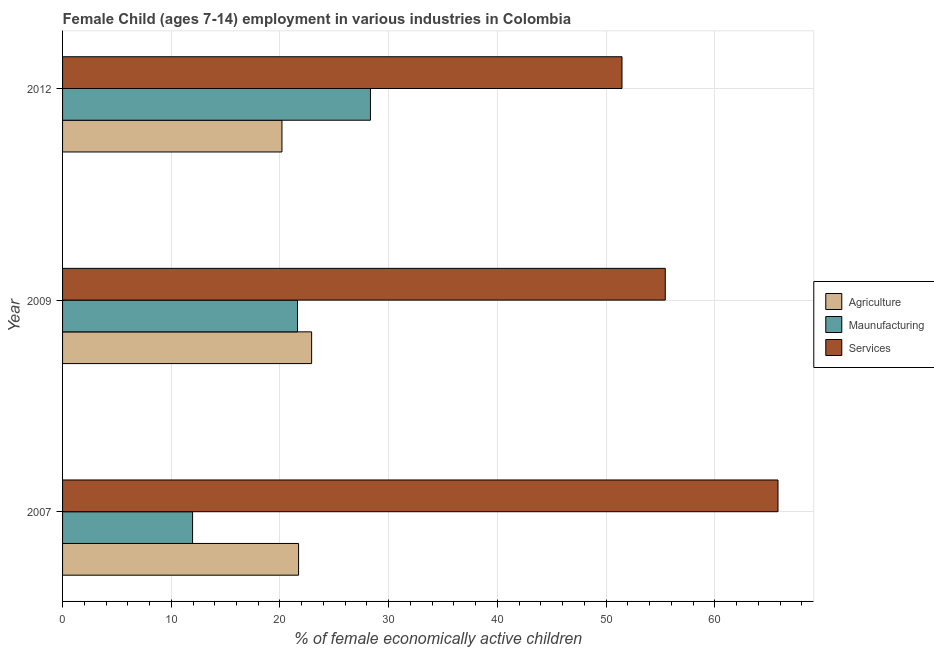How many groups of bars are there?
Provide a short and direct response. 3. Are the number of bars per tick equal to the number of legend labels?
Your response must be concise. Yes. How many bars are there on the 2nd tick from the top?
Keep it short and to the point. 3. How many bars are there on the 2nd tick from the bottom?
Your answer should be compact. 3. In how many cases, is the number of bars for a given year not equal to the number of legend labels?
Keep it short and to the point. 0. What is the percentage of economically active children in manufacturing in 2007?
Your answer should be compact. 11.96. Across all years, what is the maximum percentage of economically active children in agriculture?
Ensure brevity in your answer.  22.91. Across all years, what is the minimum percentage of economically active children in manufacturing?
Keep it short and to the point. 11.96. What is the total percentage of economically active children in agriculture in the graph?
Your response must be concise. 64.8. What is the difference between the percentage of economically active children in services in 2009 and that in 2012?
Make the answer very short. 3.98. What is the difference between the percentage of economically active children in manufacturing in 2007 and the percentage of economically active children in services in 2009?
Keep it short and to the point. -43.48. What is the average percentage of economically active children in services per year?
Your answer should be very brief. 57.57. In the year 2009, what is the difference between the percentage of economically active children in services and percentage of economically active children in agriculture?
Offer a terse response. 32.53. What is the ratio of the percentage of economically active children in agriculture in 2007 to that in 2012?
Give a very brief answer. 1.08. Is the percentage of economically active children in manufacturing in 2007 less than that in 2012?
Ensure brevity in your answer.  Yes. Is the difference between the percentage of economically active children in services in 2007 and 2009 greater than the difference between the percentage of economically active children in manufacturing in 2007 and 2009?
Offer a terse response. Yes. What is the difference between the highest and the second highest percentage of economically active children in manufacturing?
Your answer should be very brief. 6.71. What is the difference between the highest and the lowest percentage of economically active children in manufacturing?
Offer a terse response. 16.36. In how many years, is the percentage of economically active children in services greater than the average percentage of economically active children in services taken over all years?
Your response must be concise. 1. Is the sum of the percentage of economically active children in agriculture in 2007 and 2012 greater than the maximum percentage of economically active children in services across all years?
Your answer should be compact. No. What does the 1st bar from the top in 2009 represents?
Ensure brevity in your answer.  Services. What does the 3rd bar from the bottom in 2009 represents?
Your response must be concise. Services. Is it the case that in every year, the sum of the percentage of economically active children in agriculture and percentage of economically active children in manufacturing is greater than the percentage of economically active children in services?
Offer a terse response. No. How many years are there in the graph?
Your answer should be very brief. 3. Are the values on the major ticks of X-axis written in scientific E-notation?
Your answer should be very brief. No. Does the graph contain any zero values?
Provide a succinct answer. No. Does the graph contain grids?
Make the answer very short. Yes. How many legend labels are there?
Your answer should be compact. 3. How are the legend labels stacked?
Offer a terse response. Vertical. What is the title of the graph?
Your response must be concise. Female Child (ages 7-14) employment in various industries in Colombia. Does "Ireland" appear as one of the legend labels in the graph?
Keep it short and to the point. No. What is the label or title of the X-axis?
Ensure brevity in your answer.  % of female economically active children. What is the label or title of the Y-axis?
Your answer should be compact. Year. What is the % of female economically active children in Agriculture in 2007?
Ensure brevity in your answer.  21.71. What is the % of female economically active children in Maunufacturing in 2007?
Your answer should be compact. 11.96. What is the % of female economically active children of Services in 2007?
Your answer should be very brief. 65.81. What is the % of female economically active children of Agriculture in 2009?
Ensure brevity in your answer.  22.91. What is the % of female economically active children in Maunufacturing in 2009?
Your response must be concise. 21.61. What is the % of female economically active children of Services in 2009?
Offer a very short reply. 55.44. What is the % of female economically active children in Agriculture in 2012?
Keep it short and to the point. 20.18. What is the % of female economically active children of Maunufacturing in 2012?
Keep it short and to the point. 28.32. What is the % of female economically active children in Services in 2012?
Ensure brevity in your answer.  51.46. Across all years, what is the maximum % of female economically active children in Agriculture?
Make the answer very short. 22.91. Across all years, what is the maximum % of female economically active children of Maunufacturing?
Give a very brief answer. 28.32. Across all years, what is the maximum % of female economically active children of Services?
Provide a short and direct response. 65.81. Across all years, what is the minimum % of female economically active children in Agriculture?
Your response must be concise. 20.18. Across all years, what is the minimum % of female economically active children in Maunufacturing?
Your answer should be very brief. 11.96. Across all years, what is the minimum % of female economically active children of Services?
Your answer should be very brief. 51.46. What is the total % of female economically active children of Agriculture in the graph?
Make the answer very short. 64.8. What is the total % of female economically active children of Maunufacturing in the graph?
Your answer should be very brief. 61.89. What is the total % of female economically active children in Services in the graph?
Provide a succinct answer. 172.71. What is the difference between the % of female economically active children in Maunufacturing in 2007 and that in 2009?
Give a very brief answer. -9.65. What is the difference between the % of female economically active children in Services in 2007 and that in 2009?
Your answer should be compact. 10.37. What is the difference between the % of female economically active children of Agriculture in 2007 and that in 2012?
Ensure brevity in your answer.  1.53. What is the difference between the % of female economically active children of Maunufacturing in 2007 and that in 2012?
Offer a very short reply. -16.36. What is the difference between the % of female economically active children of Services in 2007 and that in 2012?
Ensure brevity in your answer.  14.35. What is the difference between the % of female economically active children in Agriculture in 2009 and that in 2012?
Make the answer very short. 2.73. What is the difference between the % of female economically active children in Maunufacturing in 2009 and that in 2012?
Ensure brevity in your answer.  -6.71. What is the difference between the % of female economically active children of Services in 2009 and that in 2012?
Your answer should be very brief. 3.98. What is the difference between the % of female economically active children of Agriculture in 2007 and the % of female economically active children of Maunufacturing in 2009?
Offer a terse response. 0.1. What is the difference between the % of female economically active children in Agriculture in 2007 and the % of female economically active children in Services in 2009?
Give a very brief answer. -33.73. What is the difference between the % of female economically active children of Maunufacturing in 2007 and the % of female economically active children of Services in 2009?
Your answer should be compact. -43.48. What is the difference between the % of female economically active children in Agriculture in 2007 and the % of female economically active children in Maunufacturing in 2012?
Your answer should be compact. -6.61. What is the difference between the % of female economically active children in Agriculture in 2007 and the % of female economically active children in Services in 2012?
Your answer should be very brief. -29.75. What is the difference between the % of female economically active children in Maunufacturing in 2007 and the % of female economically active children in Services in 2012?
Offer a very short reply. -39.5. What is the difference between the % of female economically active children in Agriculture in 2009 and the % of female economically active children in Maunufacturing in 2012?
Your answer should be very brief. -5.41. What is the difference between the % of female economically active children of Agriculture in 2009 and the % of female economically active children of Services in 2012?
Give a very brief answer. -28.55. What is the difference between the % of female economically active children in Maunufacturing in 2009 and the % of female economically active children in Services in 2012?
Offer a very short reply. -29.85. What is the average % of female economically active children of Agriculture per year?
Your answer should be compact. 21.6. What is the average % of female economically active children in Maunufacturing per year?
Make the answer very short. 20.63. What is the average % of female economically active children in Services per year?
Provide a short and direct response. 57.57. In the year 2007, what is the difference between the % of female economically active children in Agriculture and % of female economically active children in Maunufacturing?
Offer a very short reply. 9.75. In the year 2007, what is the difference between the % of female economically active children in Agriculture and % of female economically active children in Services?
Your answer should be compact. -44.1. In the year 2007, what is the difference between the % of female economically active children of Maunufacturing and % of female economically active children of Services?
Your response must be concise. -53.85. In the year 2009, what is the difference between the % of female economically active children in Agriculture and % of female economically active children in Maunufacturing?
Ensure brevity in your answer.  1.3. In the year 2009, what is the difference between the % of female economically active children of Agriculture and % of female economically active children of Services?
Offer a terse response. -32.53. In the year 2009, what is the difference between the % of female economically active children in Maunufacturing and % of female economically active children in Services?
Your answer should be compact. -33.83. In the year 2012, what is the difference between the % of female economically active children in Agriculture and % of female economically active children in Maunufacturing?
Keep it short and to the point. -8.14. In the year 2012, what is the difference between the % of female economically active children in Agriculture and % of female economically active children in Services?
Your answer should be very brief. -31.28. In the year 2012, what is the difference between the % of female economically active children of Maunufacturing and % of female economically active children of Services?
Make the answer very short. -23.14. What is the ratio of the % of female economically active children in Agriculture in 2007 to that in 2009?
Your response must be concise. 0.95. What is the ratio of the % of female economically active children of Maunufacturing in 2007 to that in 2009?
Make the answer very short. 0.55. What is the ratio of the % of female economically active children in Services in 2007 to that in 2009?
Your response must be concise. 1.19. What is the ratio of the % of female economically active children of Agriculture in 2007 to that in 2012?
Keep it short and to the point. 1.08. What is the ratio of the % of female economically active children in Maunufacturing in 2007 to that in 2012?
Ensure brevity in your answer.  0.42. What is the ratio of the % of female economically active children in Services in 2007 to that in 2012?
Ensure brevity in your answer.  1.28. What is the ratio of the % of female economically active children of Agriculture in 2009 to that in 2012?
Ensure brevity in your answer.  1.14. What is the ratio of the % of female economically active children of Maunufacturing in 2009 to that in 2012?
Your response must be concise. 0.76. What is the ratio of the % of female economically active children in Services in 2009 to that in 2012?
Make the answer very short. 1.08. What is the difference between the highest and the second highest % of female economically active children of Agriculture?
Provide a succinct answer. 1.2. What is the difference between the highest and the second highest % of female economically active children of Maunufacturing?
Offer a very short reply. 6.71. What is the difference between the highest and the second highest % of female economically active children of Services?
Provide a succinct answer. 10.37. What is the difference between the highest and the lowest % of female economically active children of Agriculture?
Ensure brevity in your answer.  2.73. What is the difference between the highest and the lowest % of female economically active children in Maunufacturing?
Your answer should be compact. 16.36. What is the difference between the highest and the lowest % of female economically active children in Services?
Your response must be concise. 14.35. 